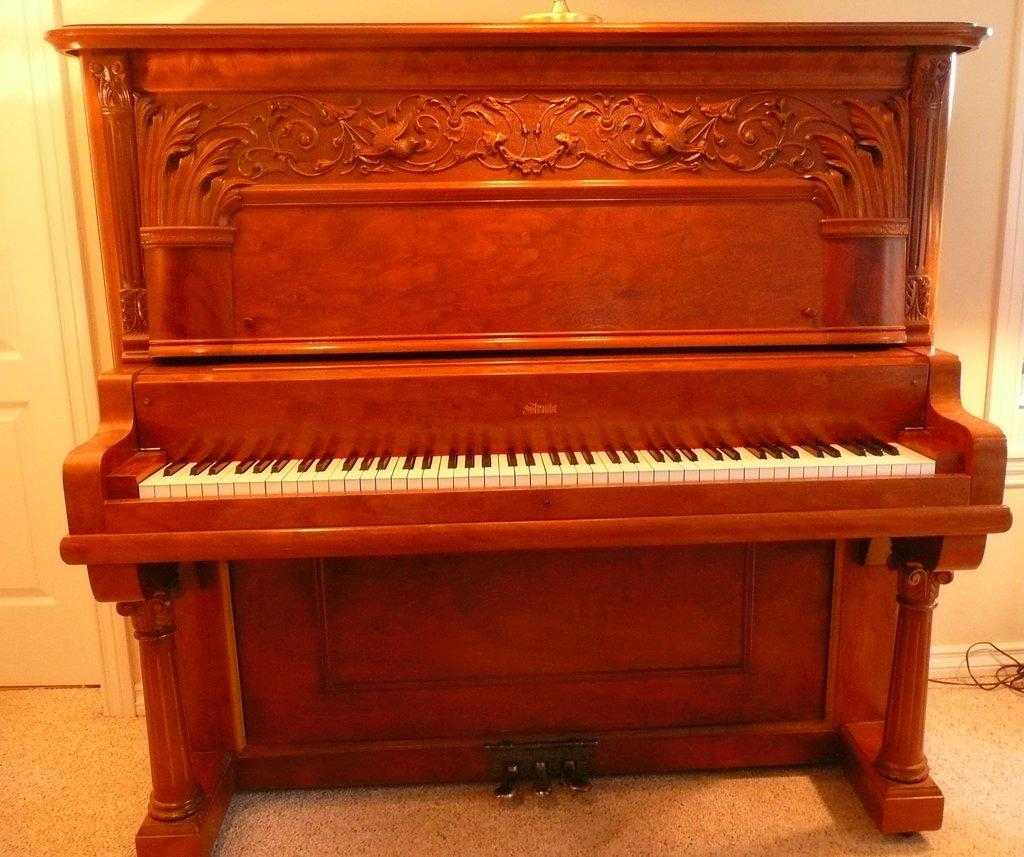What is the main object in the image? There is a piano in the image. What type of musical instrument is the piano? The piano is a keyboard instrument. What might someone be doing with the piano in the image? Someone might be playing the piano or preparing to play it. How many trucks are visible in the image? There are no trucks present in the image; it features a piano. 